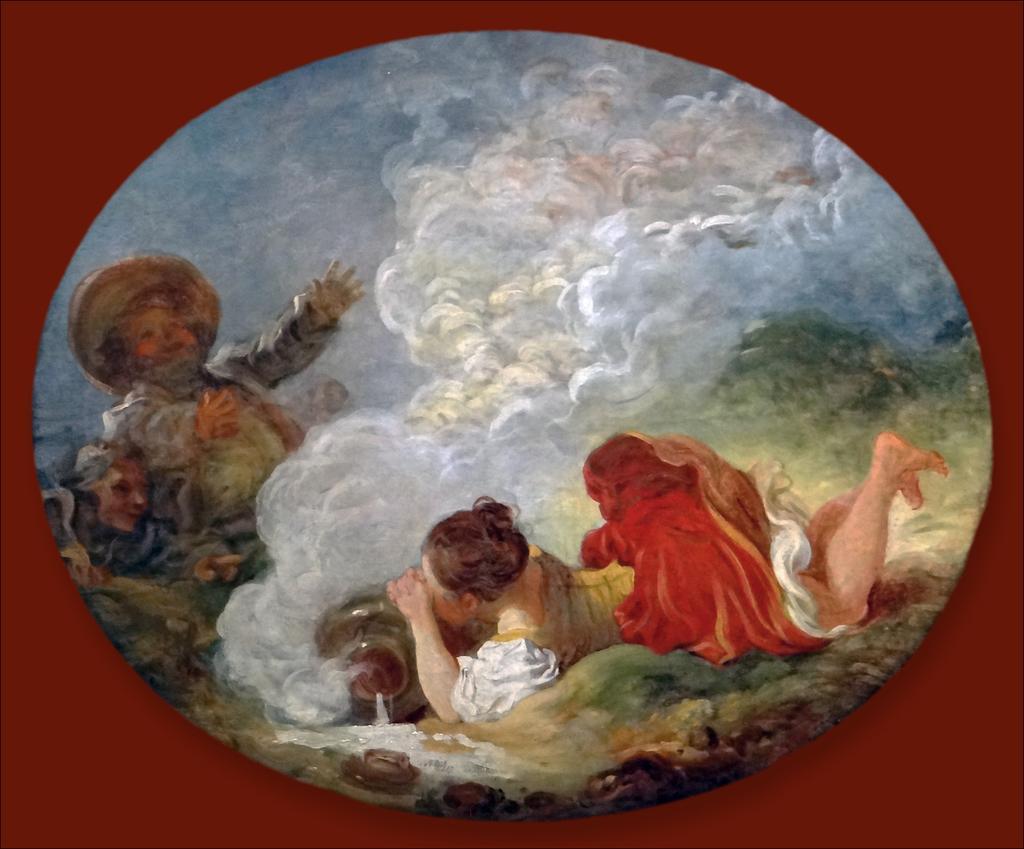Can you describe this image briefly? In this picture we can see painting consisting of a girl sleeping on the floor by closing her eyes and a man and woman staring at her and in middle we can see some fog. 